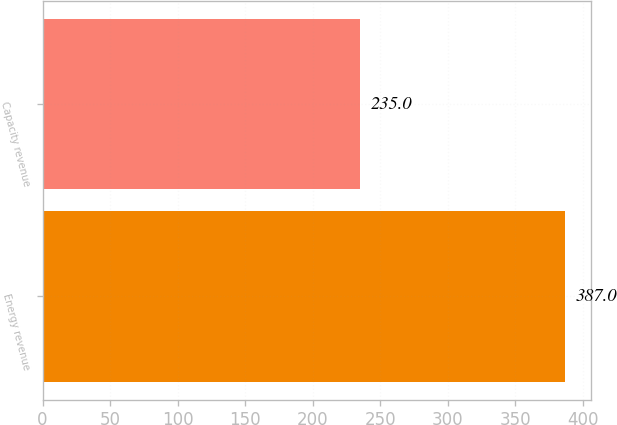<chart> <loc_0><loc_0><loc_500><loc_500><bar_chart><fcel>Energy revenue<fcel>Capacity revenue<nl><fcel>387<fcel>235<nl></chart> 